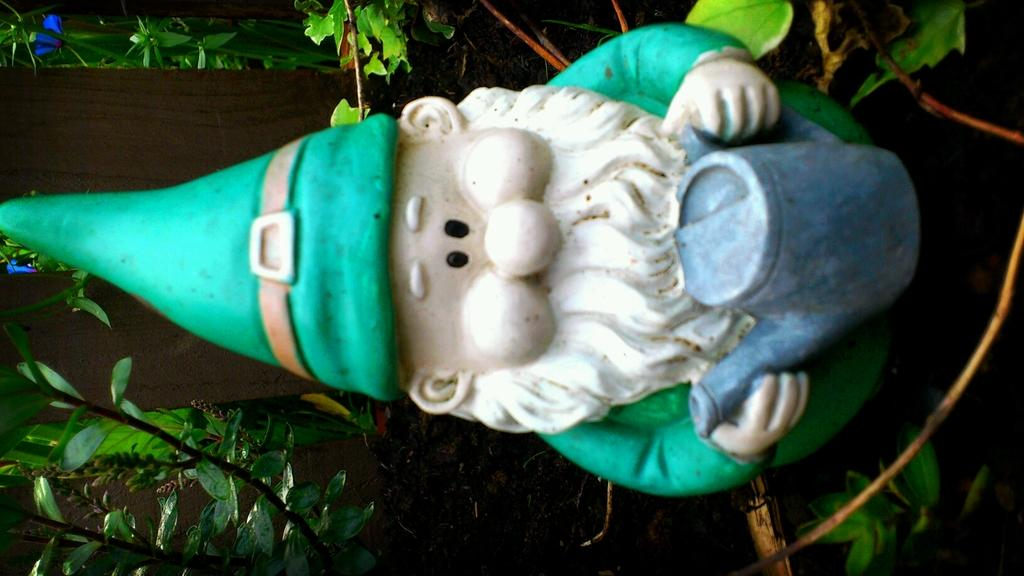How is the image oriented? A: The image is tilted. What can be seen in the center of the image? There is a small sculpture in the image. What is surrounding the sculpture? There are many plants surrounding the sculpture. What songs can be heard playing in the background of the image? There is no audio or music present in the image, so it is not possible to determine what songs might be heard. 